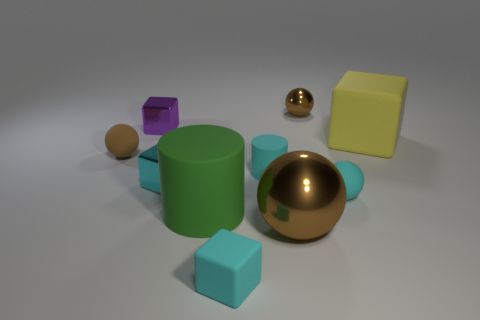Is the tiny metallic sphere the same color as the big ball?
Keep it short and to the point. Yes. Is the material of the yellow thing the same as the cyan object that is in front of the cyan ball?
Offer a terse response. Yes. What is the color of the rubber cube that is the same size as the cyan rubber cylinder?
Offer a terse response. Cyan. What size is the rubber sphere that is behind the tiny shiny cube that is in front of the big yellow rubber object?
Provide a succinct answer. Small. There is a small cylinder; is its color the same as the tiny matte ball right of the tiny cyan metallic cube?
Give a very brief answer. Yes. Is the number of cyan matte balls that are on the left side of the tiny cyan matte block less than the number of purple things?
Provide a short and direct response. Yes. How many other things are the same size as the brown matte object?
Offer a very short reply. 6. Does the small thing that is on the left side of the purple metallic object have the same shape as the large metal object?
Offer a very short reply. Yes. Are there more small cubes behind the large green cylinder than big green balls?
Provide a succinct answer. Yes. There is a tiny ball that is both behind the tiny cyan shiny cube and in front of the tiny purple cube; what is its material?
Keep it short and to the point. Rubber. 